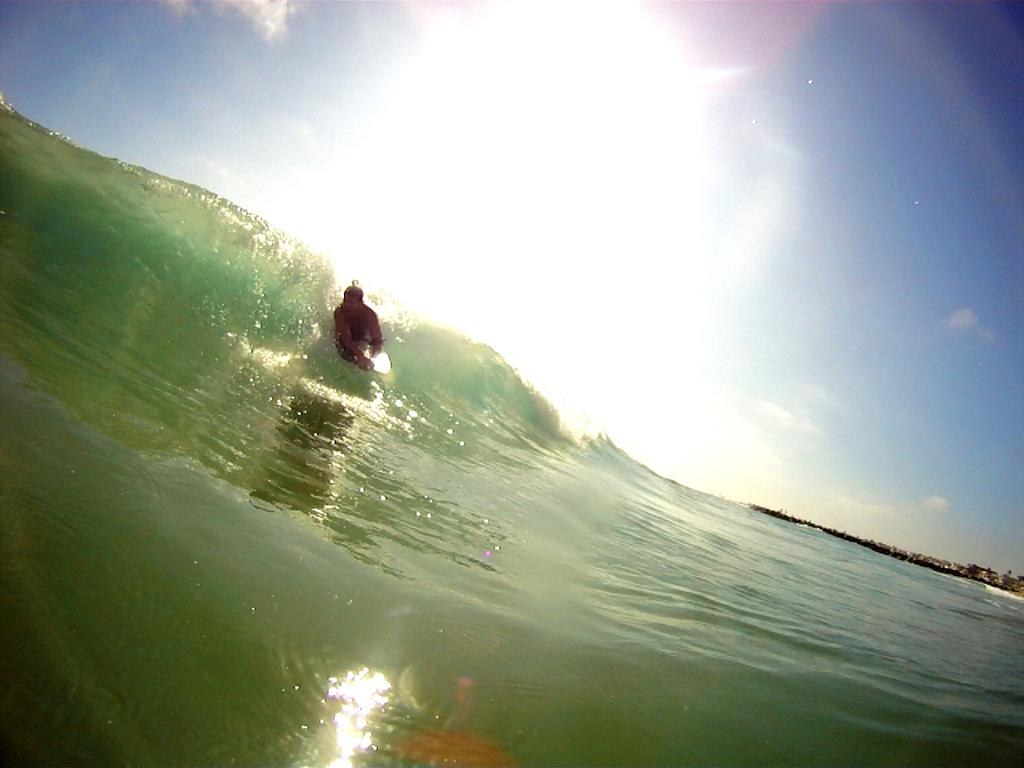What is the person in the image doing? The person is riding a surfboard in the image. Where is the person located? The person is on a tide of an ocean. What can be seen in the background of the image? There are trees and the ground visible in the background of the image. What is the weather like in the person in the image? The presence of clouds and the visible sun suggest it is partly cloudy. What type of shoes is the person wearing to surprise the downtown crowd? There is no mention of shoes, surprise, or downtown in the image. The person is wearing a wetsuit and is focused on surfing in the ocean. 